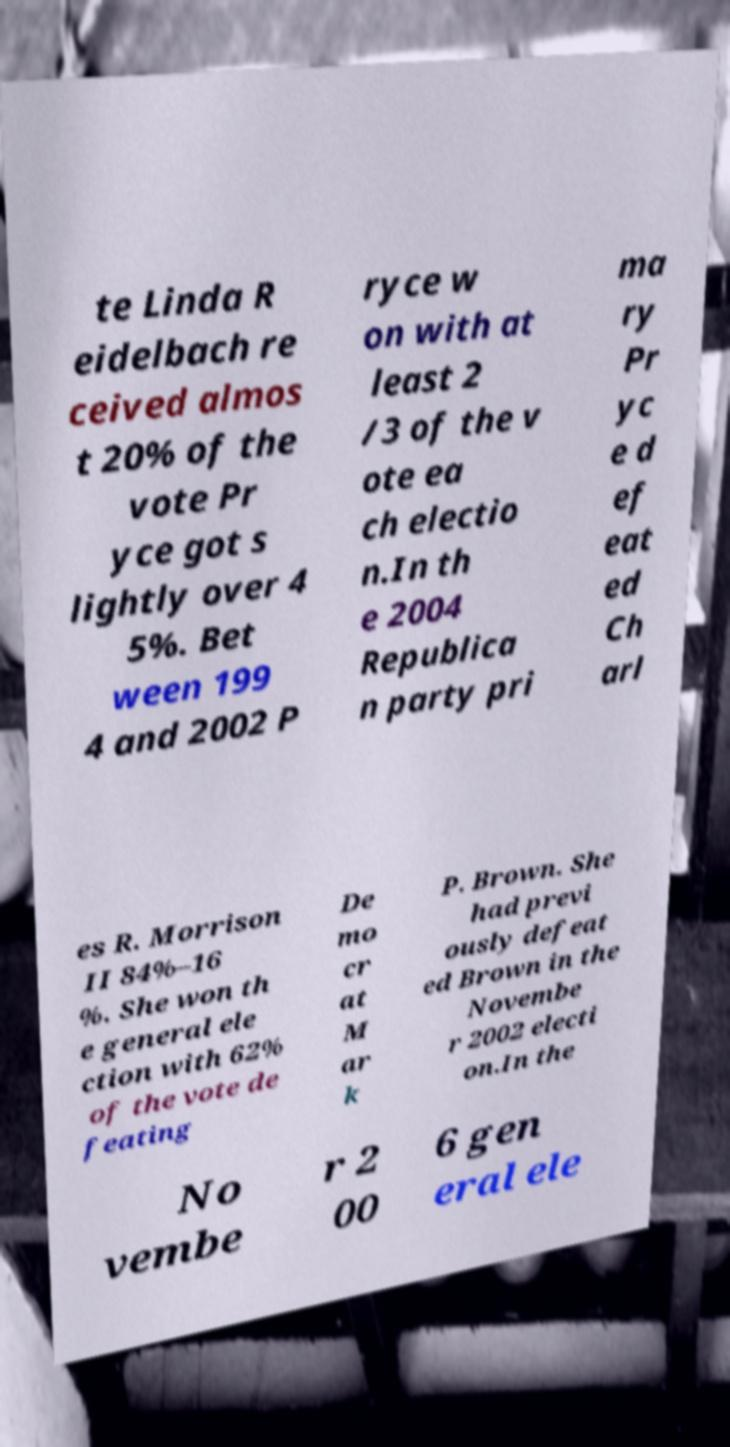I need the written content from this picture converted into text. Can you do that? te Linda R eidelbach re ceived almos t 20% of the vote Pr yce got s lightly over 4 5%. Bet ween 199 4 and 2002 P ryce w on with at least 2 /3 of the v ote ea ch electio n.In th e 2004 Republica n party pri ma ry Pr yc e d ef eat ed Ch arl es R. Morrison II 84%–16 %. She won th e general ele ction with 62% of the vote de feating De mo cr at M ar k P. Brown. She had previ ously defeat ed Brown in the Novembe r 2002 electi on.In the No vembe r 2 00 6 gen eral ele 